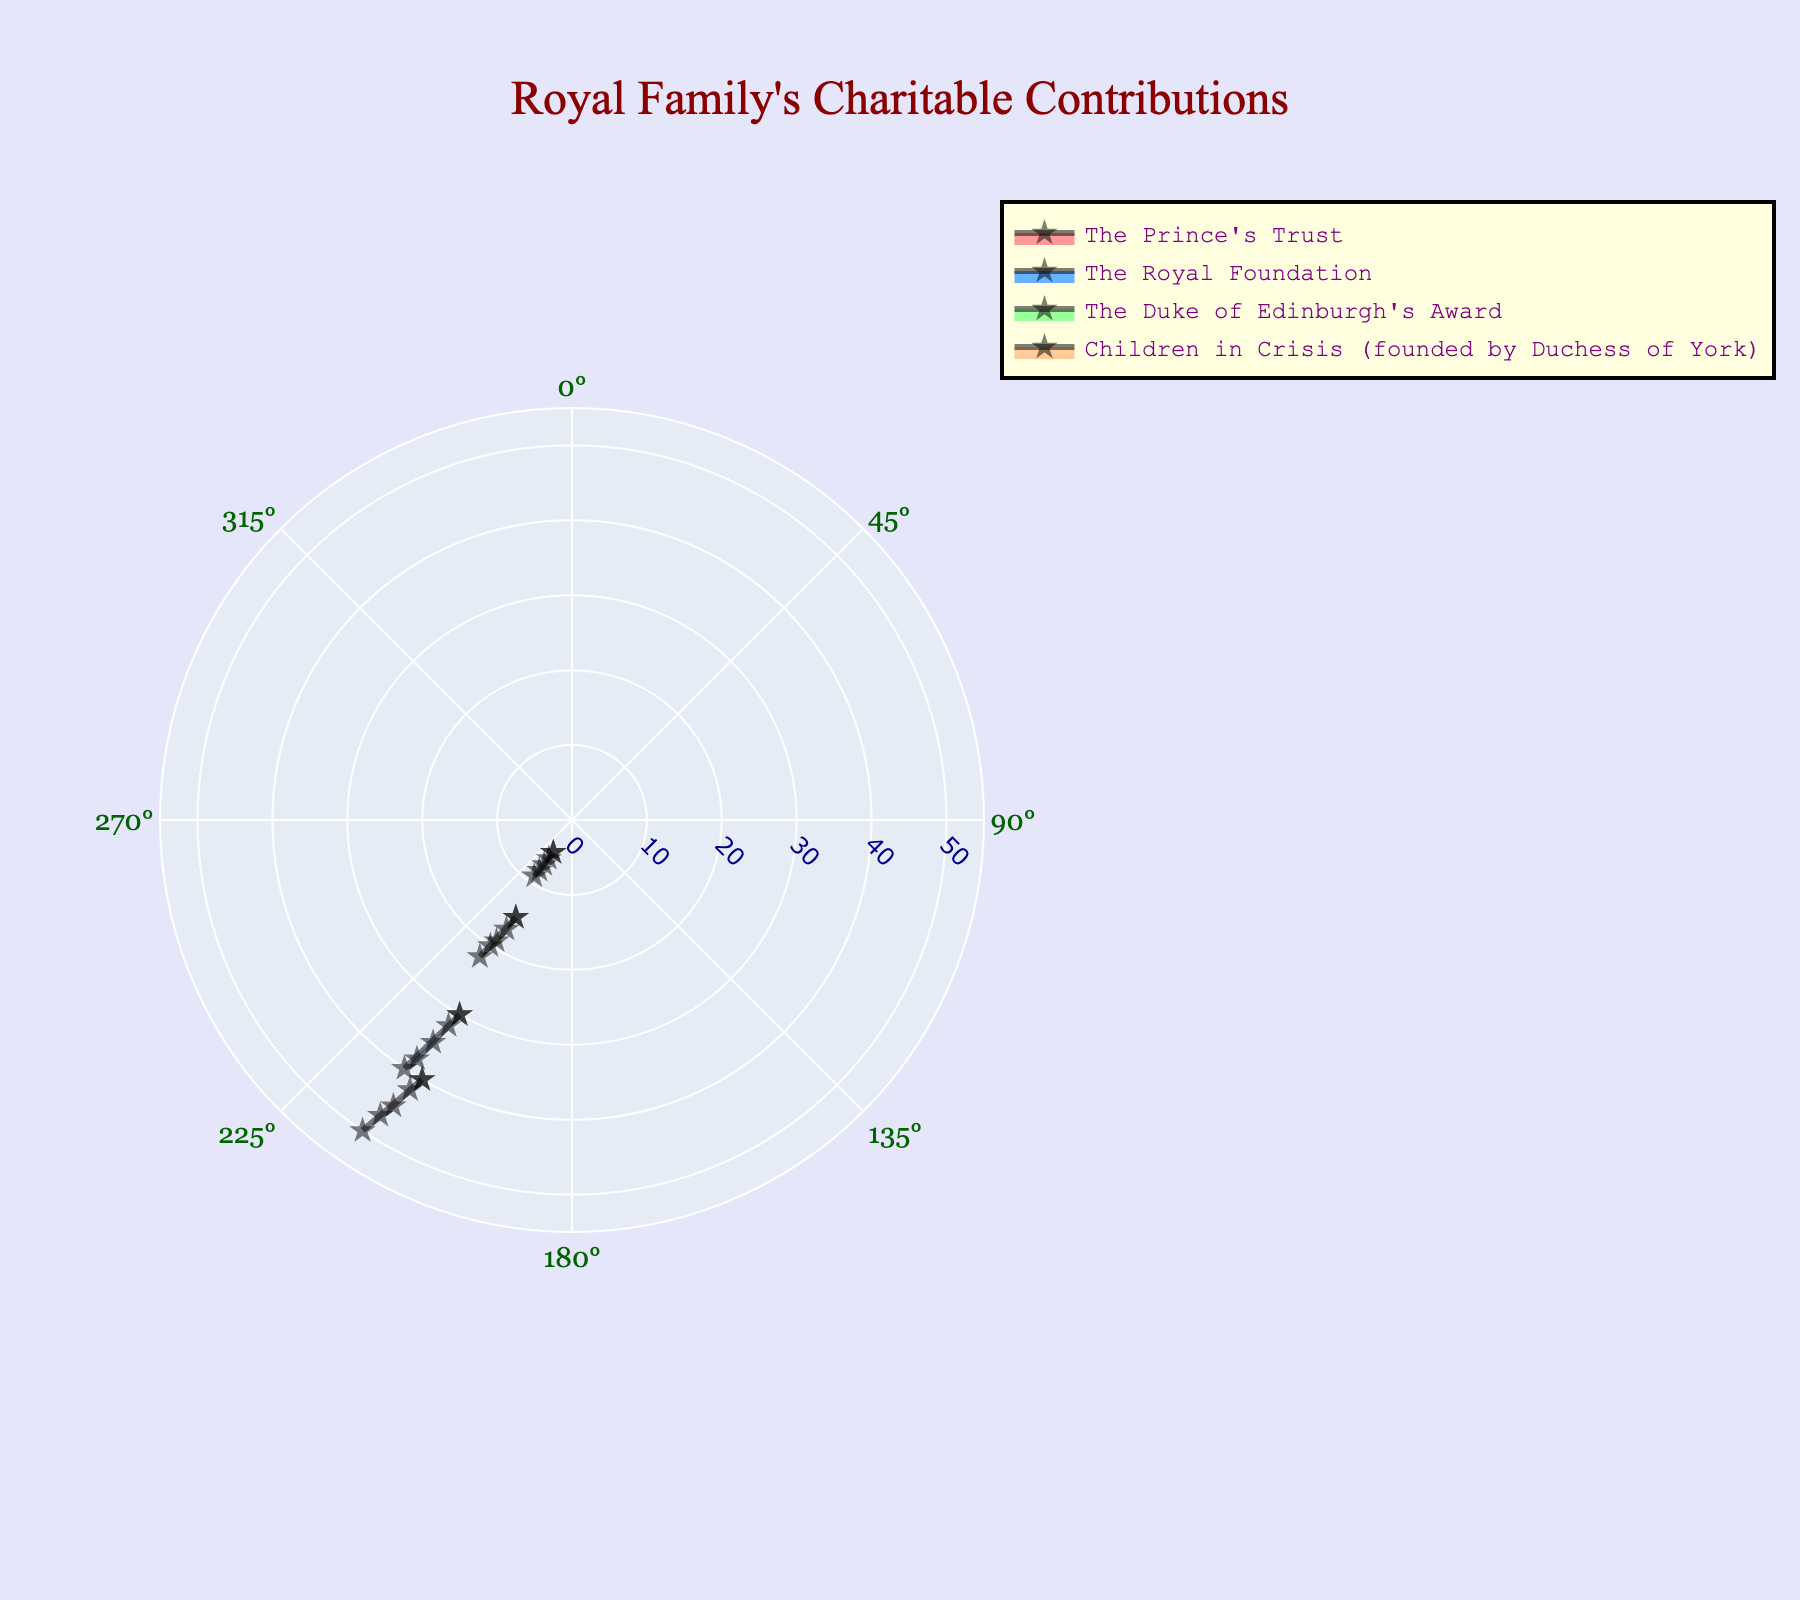What is the title of the figure? The title is usually located at the top of the figure, and in this case, it is clearly visible and formatted to stand out.
Answer: Royal Family's Charitable Contributions How many charities are represented in the figure? Each charity is represented by a different polar area, and their names are listed in the legend or on the axes. Count the distinct charities listed.
Answer: 4 Which charity had the lowest contribution in 2014? Look at the radial lines for 2014 and find the charity whose area extends the least distance from the center for that year.
Answer: Children in Crisis (founded by Duchess of York) What was the trend for the contributions by Children in Crisis from 2010 to 2014? Follow the outline of the area for Children in Crisis from 2010 to 2014. Note increases and check the consistency year over year.
Answer: Increasing trend In which year did The Duke of Edinburgh's Award receive its highest contribution? Compare the radial extent of The Duke of Edinburgh's Award's area across all years and identify the maximum point.
Answer: 2014 What was the average contribution amount for The Prince's Trust between 2010 and 2014? Sum the contributions for The Prince's Trust from 2010 to 2014 and divide by the number of years (5). Calculation: (40 + 42 + 45 + 47 + 50) / 5.
Answer: 44.8 million GBP How do the contributions to The Royal Foundation in 2012 compare to those in 2013? Observe the radial lengths for The Royal Foundation in 2012 and 2013 and compare which is longer.
Answer: 2013 is higher than 2012 Which year had the highest overall contributions when all charities are considered together? Sum the contributions of all charities for each year and compare the totals across years to find the maximum.
Answer: 2014 What is the color associated with Children in Crisis in the figure? Each charity is represented by a different colored area. Identify the color used for Children in Crisis.
Answer: Likely '#FFCC99' (light orange) Which charity saw the smallest relative increase in contributions from 2010 to 2014? Calculate the percentage increase for each charity from 2010 to 2014, then compare them to find the smallest. For example, for Children in Crisis: ((9 - 5) / 5) * 100%.
Answer: The Duke of Edinburgh's Award or Children in Crisis, needs exact calculation 